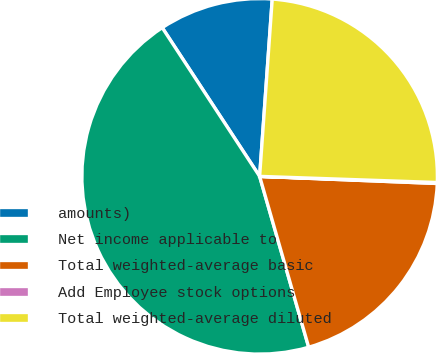<chart> <loc_0><loc_0><loc_500><loc_500><pie_chart><fcel>amounts)<fcel>Net income applicable to<fcel>Total weighted-average basic<fcel>Add Employee stock options<fcel>Total weighted-average diluted<nl><fcel>10.36%<fcel>45.22%<fcel>19.91%<fcel>0.09%<fcel>24.42%<nl></chart> 